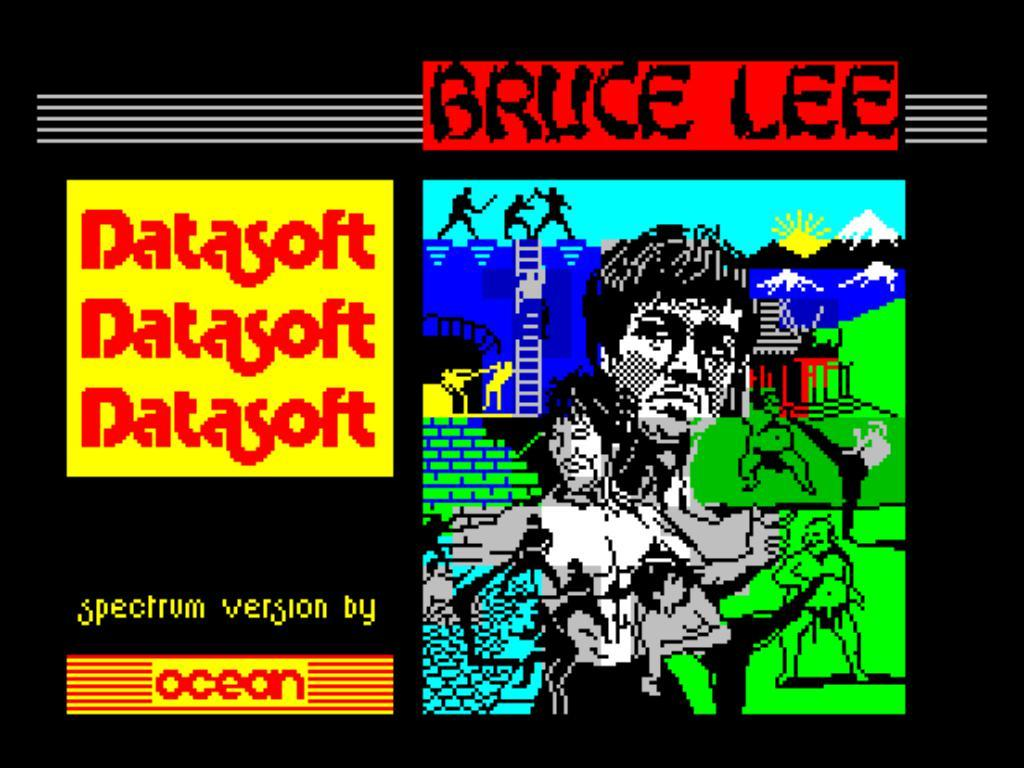<image>
Offer a succinct explanation of the picture presented. Bruce Lee video advertisement made by Datasoft and Ocean 